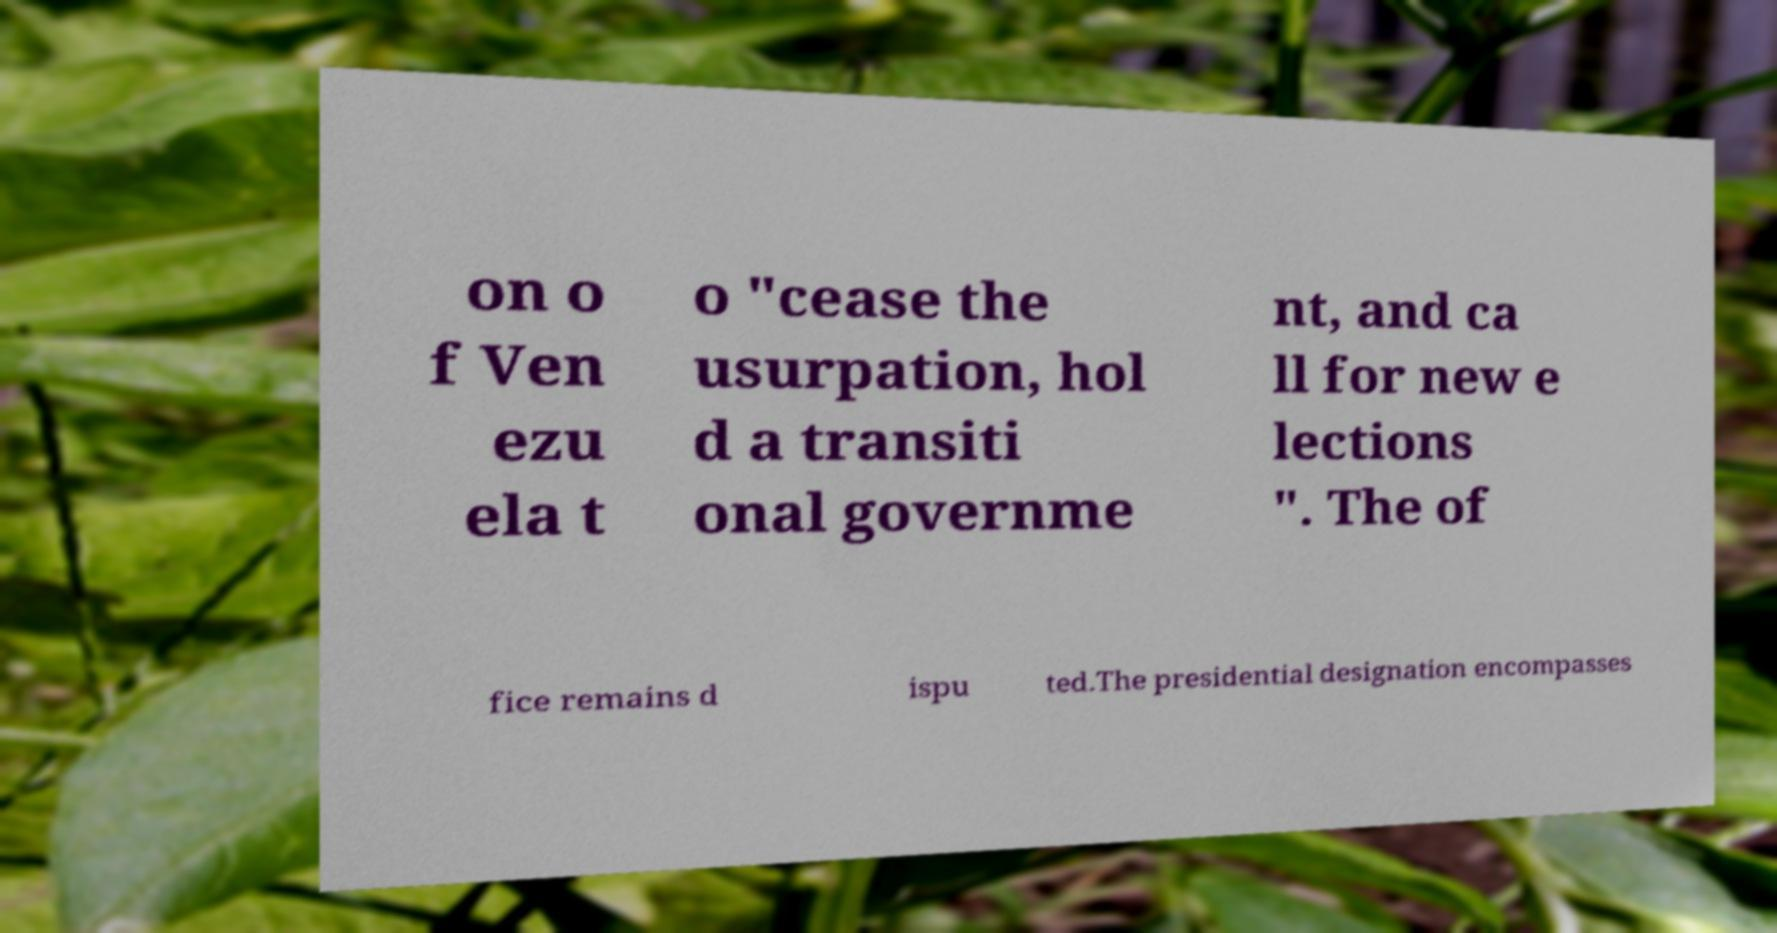Can you accurately transcribe the text from the provided image for me? on o f Ven ezu ela t o "cease the usurpation, hol d a transiti onal governme nt, and ca ll for new e lections ". The of fice remains d ispu ted.The presidential designation encompasses 